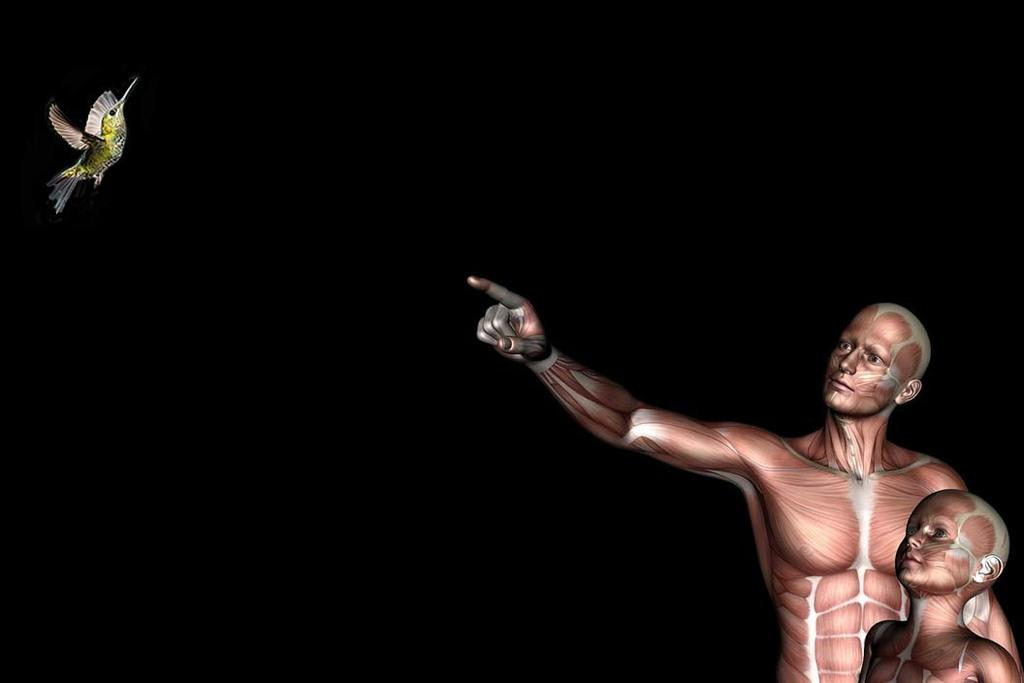How many people are in the image? There are two people standing in the image. Where are the people located in the image? The people are on the right side of the image. What other living creature can be seen in the image? There is a bird in the image. Where is the bird located in the image? The bird is on the left side of the image. What is the color of the background in the image? The background of the image is dark. What type of wheel can be seen on the page in the image? There is no wheel or page present in the image. Which direction is the north indicated in the image? There is no indication of direction or north in the image. 